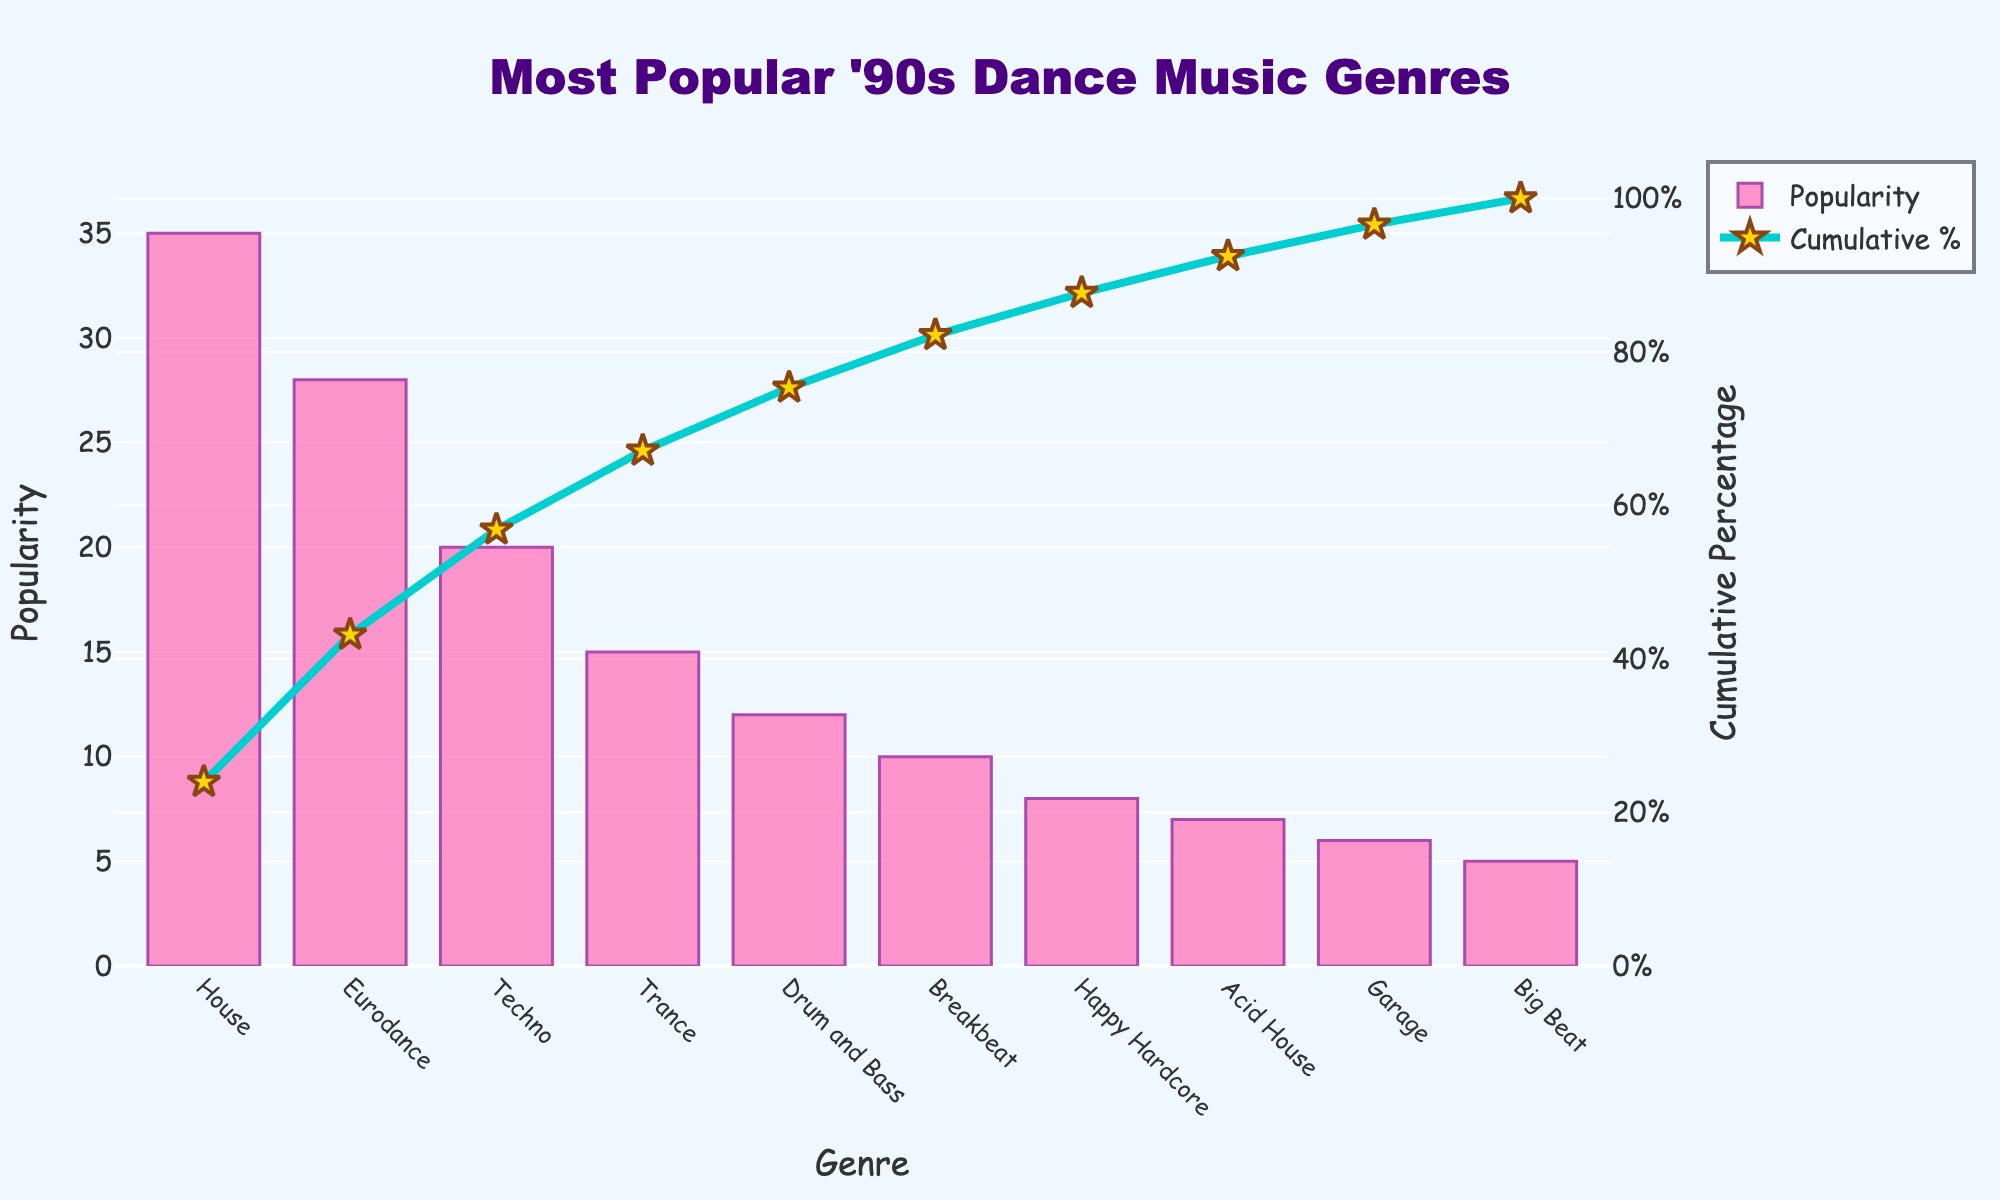What is the title of the figure? The title of the figure is prominently displayed at the top of the chart. It states, "Most Popular '90s Dance Music Genres."
Answer: Most Popular '90s Dance Music Genres Which genre is the most popular according to the Pareto chart? The tallest bar on the chart, representing the highest value on the Y-axis (Popularity), corresponds to the "House" genre, indicating it is the most popular.
Answer: House What is the cumulative percentage of popularity for the three most popular genres combined? The cumulative percentage for the three most popular genres (House, Eurodance, and Techno) needs to be summed up. The cumulative percentages are 35% (House) + 28% (Eurodance) + 20% (Techno), so the cumulative percentage is 35% + 28% = 63%; 63% + 20% = 83%.
Answer: 83% How many genres have a popularity less than 10? By inspecting the heights of the bars and their corresponding values on the Y-axis (Popularity), we can see that genres classified below 10 in popularity are Happy Hardcore (8), Acid House (7), Garage (6), and Big Beat (5). Hence, there are four genres with a popularity less than 10.
Answer: 4 Which genre contributes the least to the cumulative percentage? The shortest bar in the graph represents the "Big Beat" genre with a popularity of 5, which contributes the least to the cumulative percentage.
Answer: Big Beat What is the cumulative percentage at the Eurodance genre? To find the cumulative percentage, follow the line chart. For the Eurodance genre, the cumulative percentage at its corresponding point is highlighted on the secondary Y-axis (Cumulative Percentage). This reads approximately 63%.
Answer: 63% Which genre surpasses the 50% cumulative percentage of popularity? Following the cumulative percentage line, we can see that "Eurodance" represents the point where the cumulative percentage exceeds 50%.
Answer: Eurodance What is the difference in popularity between House and Breakbeat genres? The popularity of the House genre is 35 and for the Breakbeat genre is 10. Subtracting these values gives 35 - 10 = 25.
Answer: 25 How many genres have a higher popularity than Trance? Trance has a popularity of 15. The genres with higher popularity than Trance are House (35), Eurodance (28), and Techno (20). This shows that there are three genres more popular than Trance.
Answer: 3 Which genres make up over 90% of the cumulative popularity? The cumulative percentage needs to be tracked until it exceeds 90%. House (35%) + Eurodance (28%) + Techno (20%) + Trance (15%) = 98%. Thus, these genres make up over 90% of the cumulative popularity.
Answer: House, Eurodance, Techno, Trance 